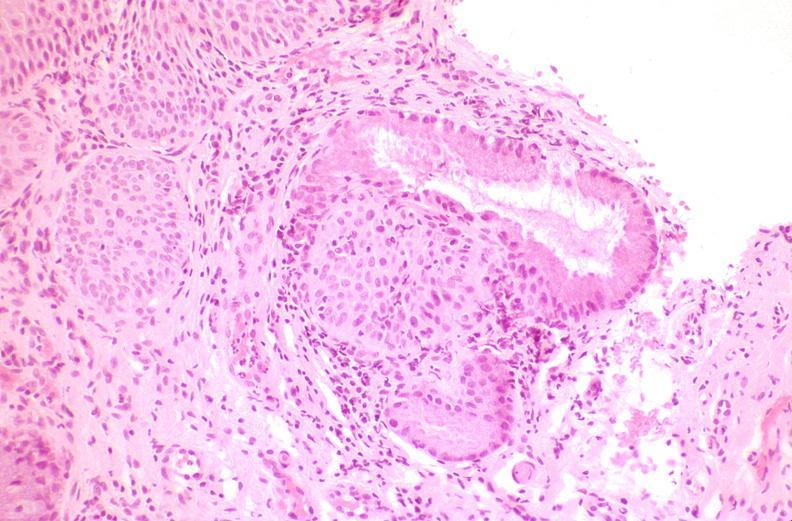what is present?
Answer the question using a single word or phrase. Female reproductive 